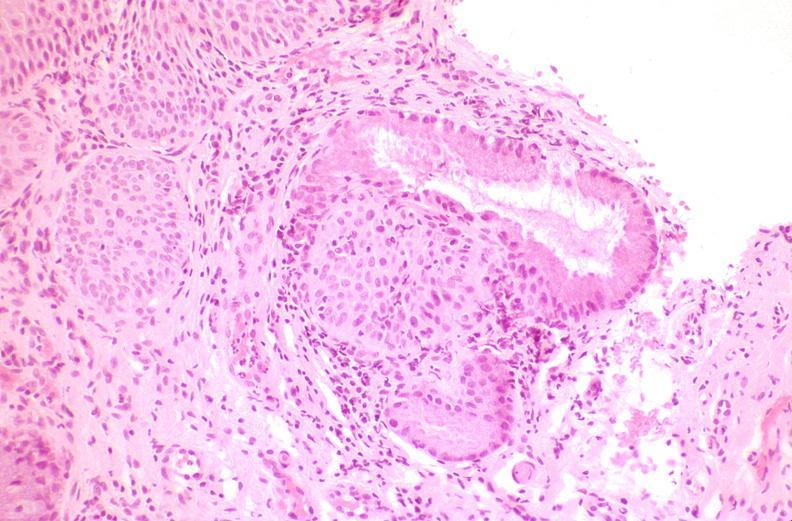what is present?
Answer the question using a single word or phrase. Female reproductive 